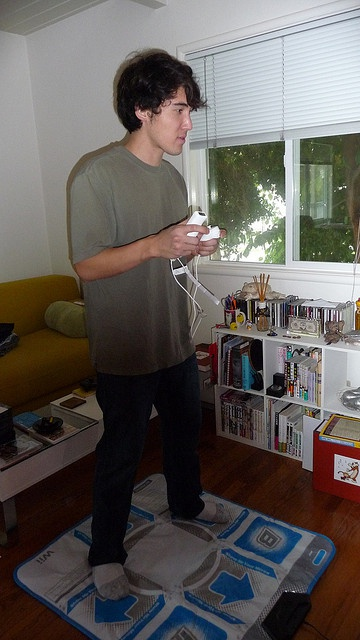Describe the objects in this image and their specific colors. I can see people in gray, black, and maroon tones, couch in gray, black, maroon, and darkgreen tones, book in gray and black tones, book in gray, darkgray, and black tones, and book in gray and maroon tones in this image. 